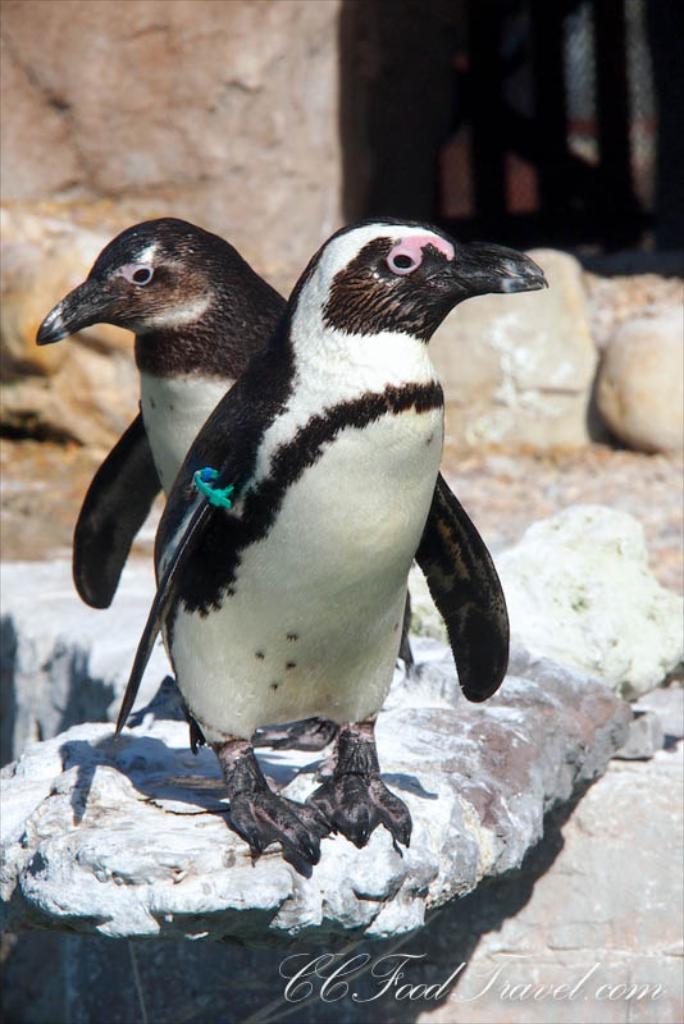Could you give a brief overview of what you see in this image? In this image we can see the two penguins on the rock. In the background we can see the fence and also the rocks. We can also see the text at the bottom. 